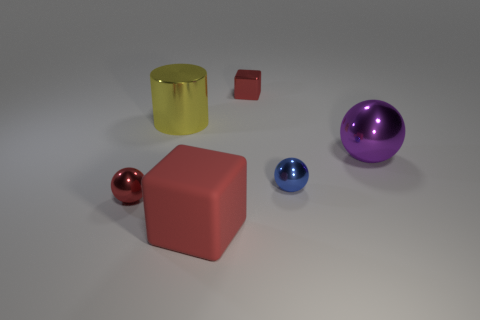Add 3 red rubber blocks. How many objects exist? 9 Subtract all cylinders. How many objects are left? 5 Subtract all tiny blue metallic objects. Subtract all big purple metallic balls. How many objects are left? 4 Add 2 big yellow shiny cylinders. How many big yellow shiny cylinders are left? 3 Add 3 large purple shiny balls. How many large purple shiny balls exist? 4 Subtract 1 red balls. How many objects are left? 5 